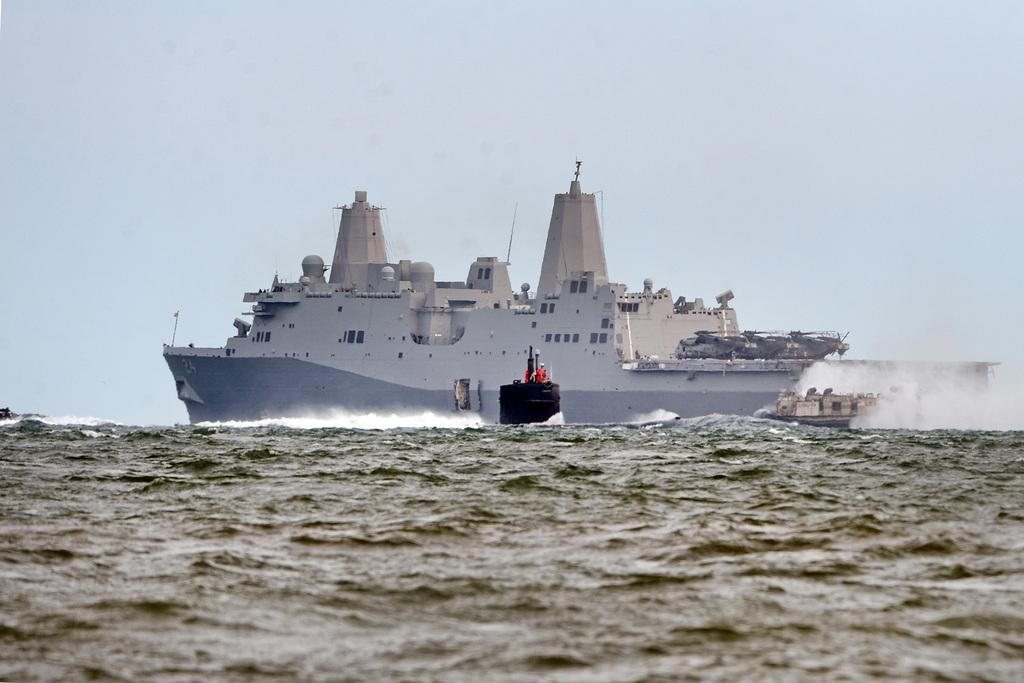What is the main subject of the image? The main subject of the image is a big ship. What is the ship doing in the image? The ship is sailing on the sea. Are there any other boats or vessels in the image? Yes, there is a small boat in the image. Where is the small boat located in relation to the big ship? The small boat is beside the big ship. What year is the book about the ship's journey published? There is no book mentioned in the image, so we cannot determine the publication year of a book about the ship's journey. Can you see any insects on the ship or the small boat? There are no insects visible in the image. 